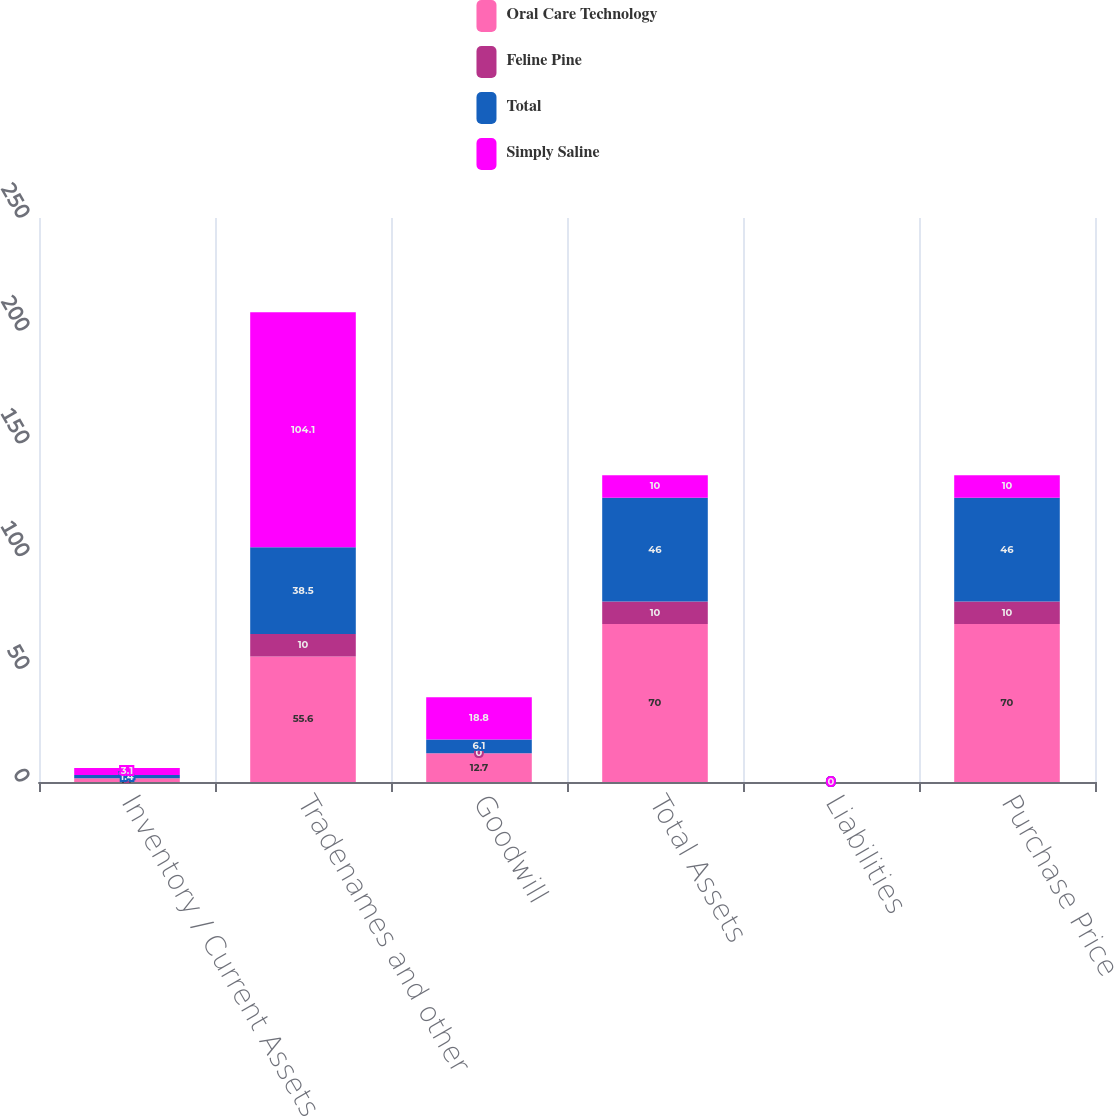Convert chart. <chart><loc_0><loc_0><loc_500><loc_500><stacked_bar_chart><ecel><fcel>Inventory / Current Assets<fcel>Tradenames and other<fcel>Goodwill<fcel>Total Assets<fcel>Liabilities<fcel>Purchase Price<nl><fcel>Oral Care Technology<fcel>1.7<fcel>55.6<fcel>12.7<fcel>70<fcel>0<fcel>70<nl><fcel>Feline Pine<fcel>0<fcel>10<fcel>0<fcel>10<fcel>0<fcel>10<nl><fcel>Total<fcel>1.4<fcel>38.5<fcel>6.1<fcel>46<fcel>0<fcel>46<nl><fcel>Simply Saline<fcel>3.1<fcel>104.1<fcel>18.8<fcel>10<fcel>0<fcel>10<nl></chart> 